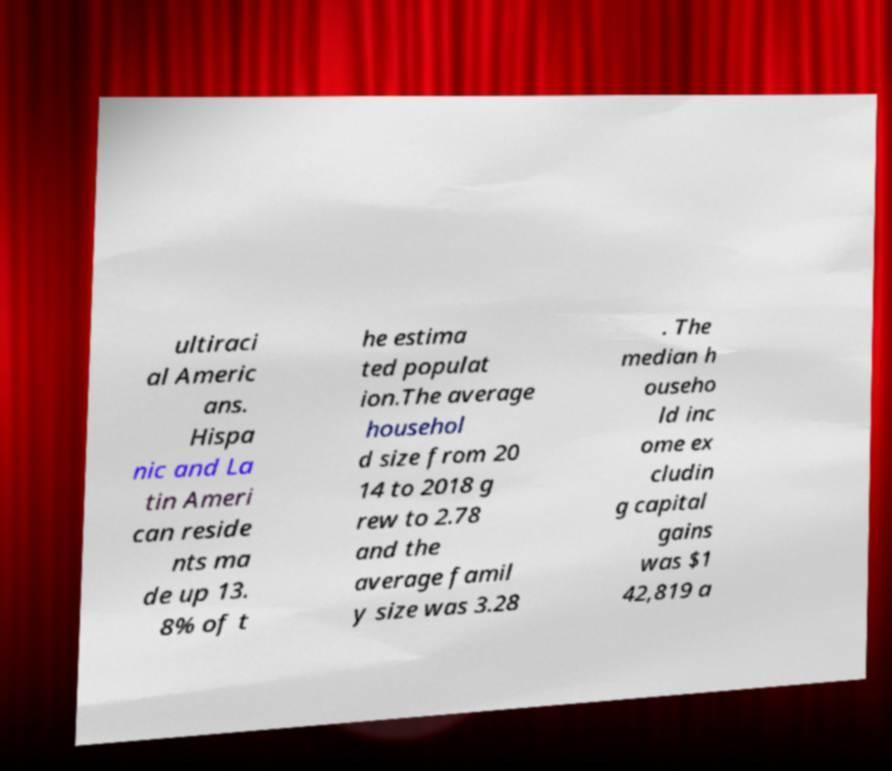Could you assist in decoding the text presented in this image and type it out clearly? ultiraci al Americ ans. Hispa nic and La tin Ameri can reside nts ma de up 13. 8% of t he estima ted populat ion.The average househol d size from 20 14 to 2018 g rew to 2.78 and the average famil y size was 3.28 . The median h ouseho ld inc ome ex cludin g capital gains was $1 42,819 a 